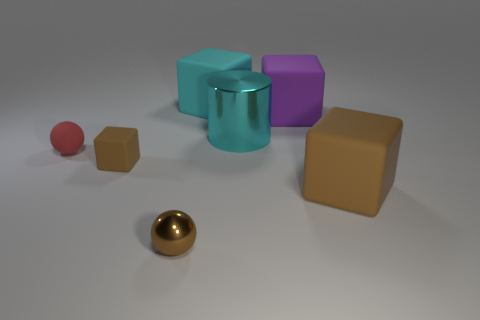Is the number of big brown objects in front of the small metal thing greater than the number of small red objects on the right side of the big brown rubber thing?
Ensure brevity in your answer.  No. Do the sphere that is behind the small brown block and the cyan thing that is behind the metallic cylinder have the same material?
Provide a succinct answer. Yes. There is a cyan cylinder; are there any tiny matte objects behind it?
Your answer should be compact. No. What number of yellow objects are either small rubber cylinders or large metallic things?
Provide a succinct answer. 0. Does the large cyan block have the same material as the purple block that is behind the tiny red rubber object?
Your answer should be compact. Yes. What size is the matte object that is the same shape as the brown metal object?
Ensure brevity in your answer.  Small. What material is the brown sphere?
Your response must be concise. Metal. There is a brown cube that is behind the big matte thing in front of the metal object that is behind the metal ball; what is it made of?
Your response must be concise. Rubber. There is a sphere that is in front of the red sphere; is its size the same as the brown thing that is right of the purple matte block?
Provide a succinct answer. No. How many other objects are the same material as the cylinder?
Ensure brevity in your answer.  1. 